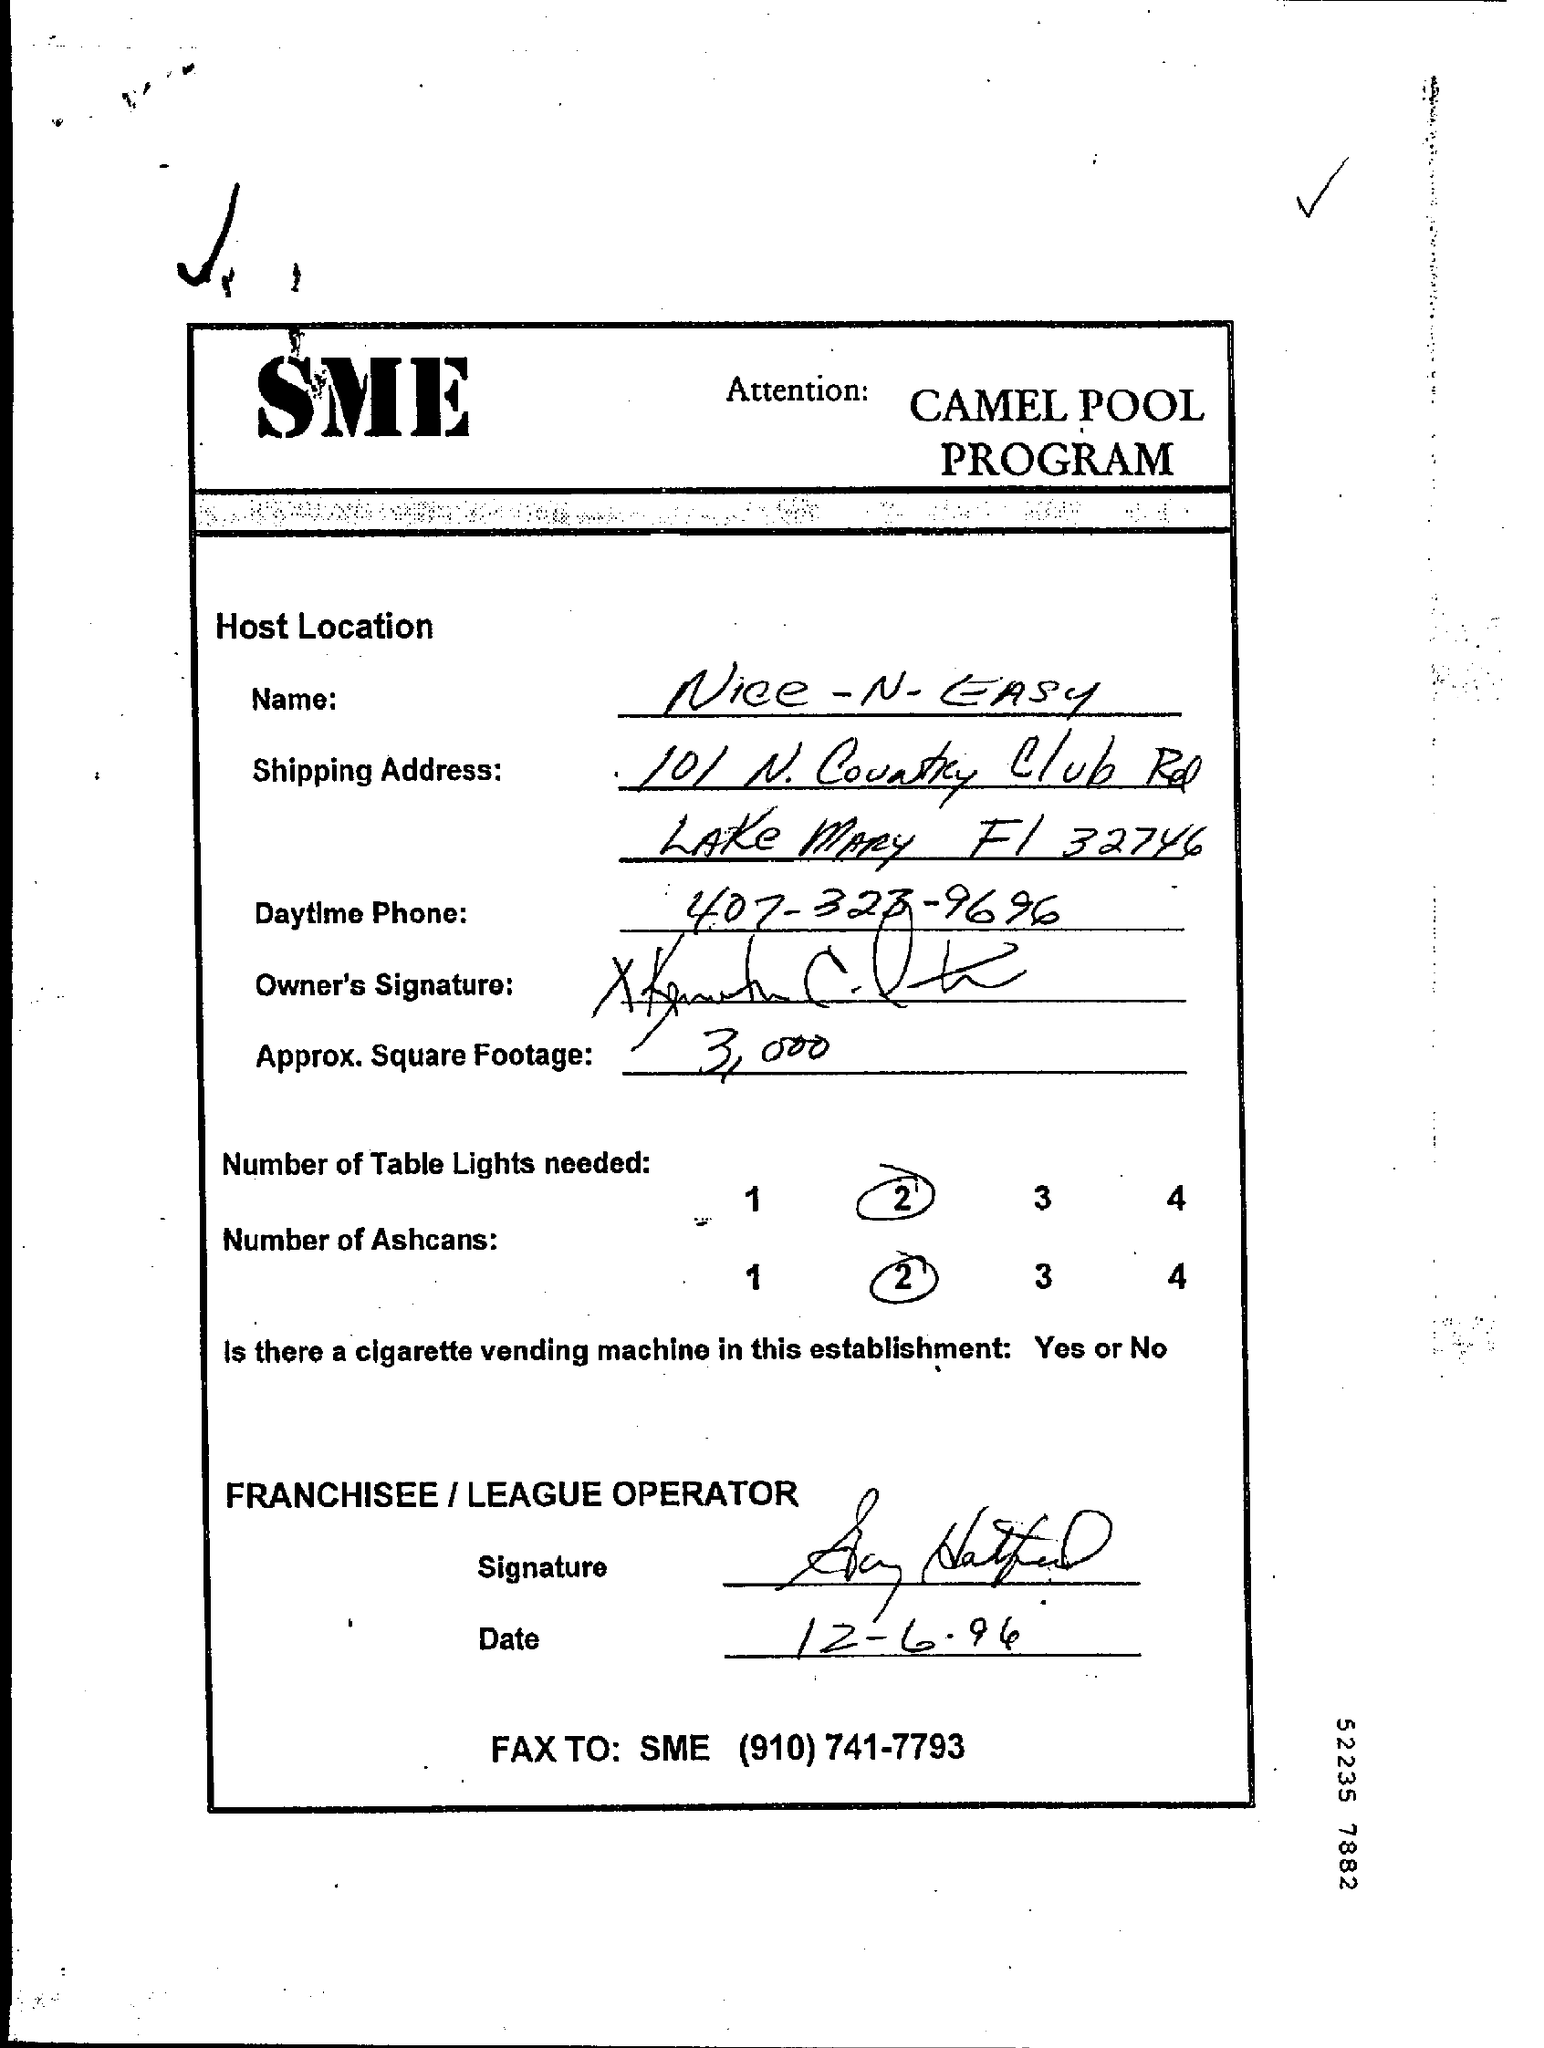Give some essential details in this illustration. It is necessary to order two Ashcans. The name given is 'nice-n-easy.' The Camel Pool Program is a specific program that is being referred to. The fax number provided is (910) 741-7793. 